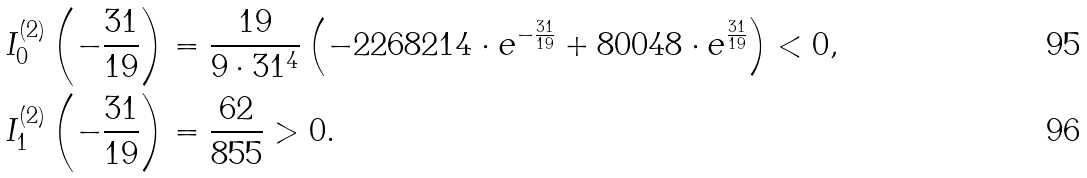<formula> <loc_0><loc_0><loc_500><loc_500>& I _ { 0 } ^ { ( 2 ) } \left ( - \frac { 3 1 } { 1 9 } \right ) = \frac { 1 9 } { 9 \cdot { 3 1 ^ { 4 } } } \left ( - 2 2 6 8 2 1 4 \cdot { e ^ { - \frac { 3 1 } { 1 9 } } } + 8 0 0 4 8 \cdot { e ^ { \frac { 3 1 } { 1 9 } } } \right ) < 0 , \\ & I _ { 1 } ^ { ( 2 ) } \left ( - \frac { 3 1 } { 1 9 } \right ) = \frac { 6 2 } { 8 5 5 } > 0 .</formula> 